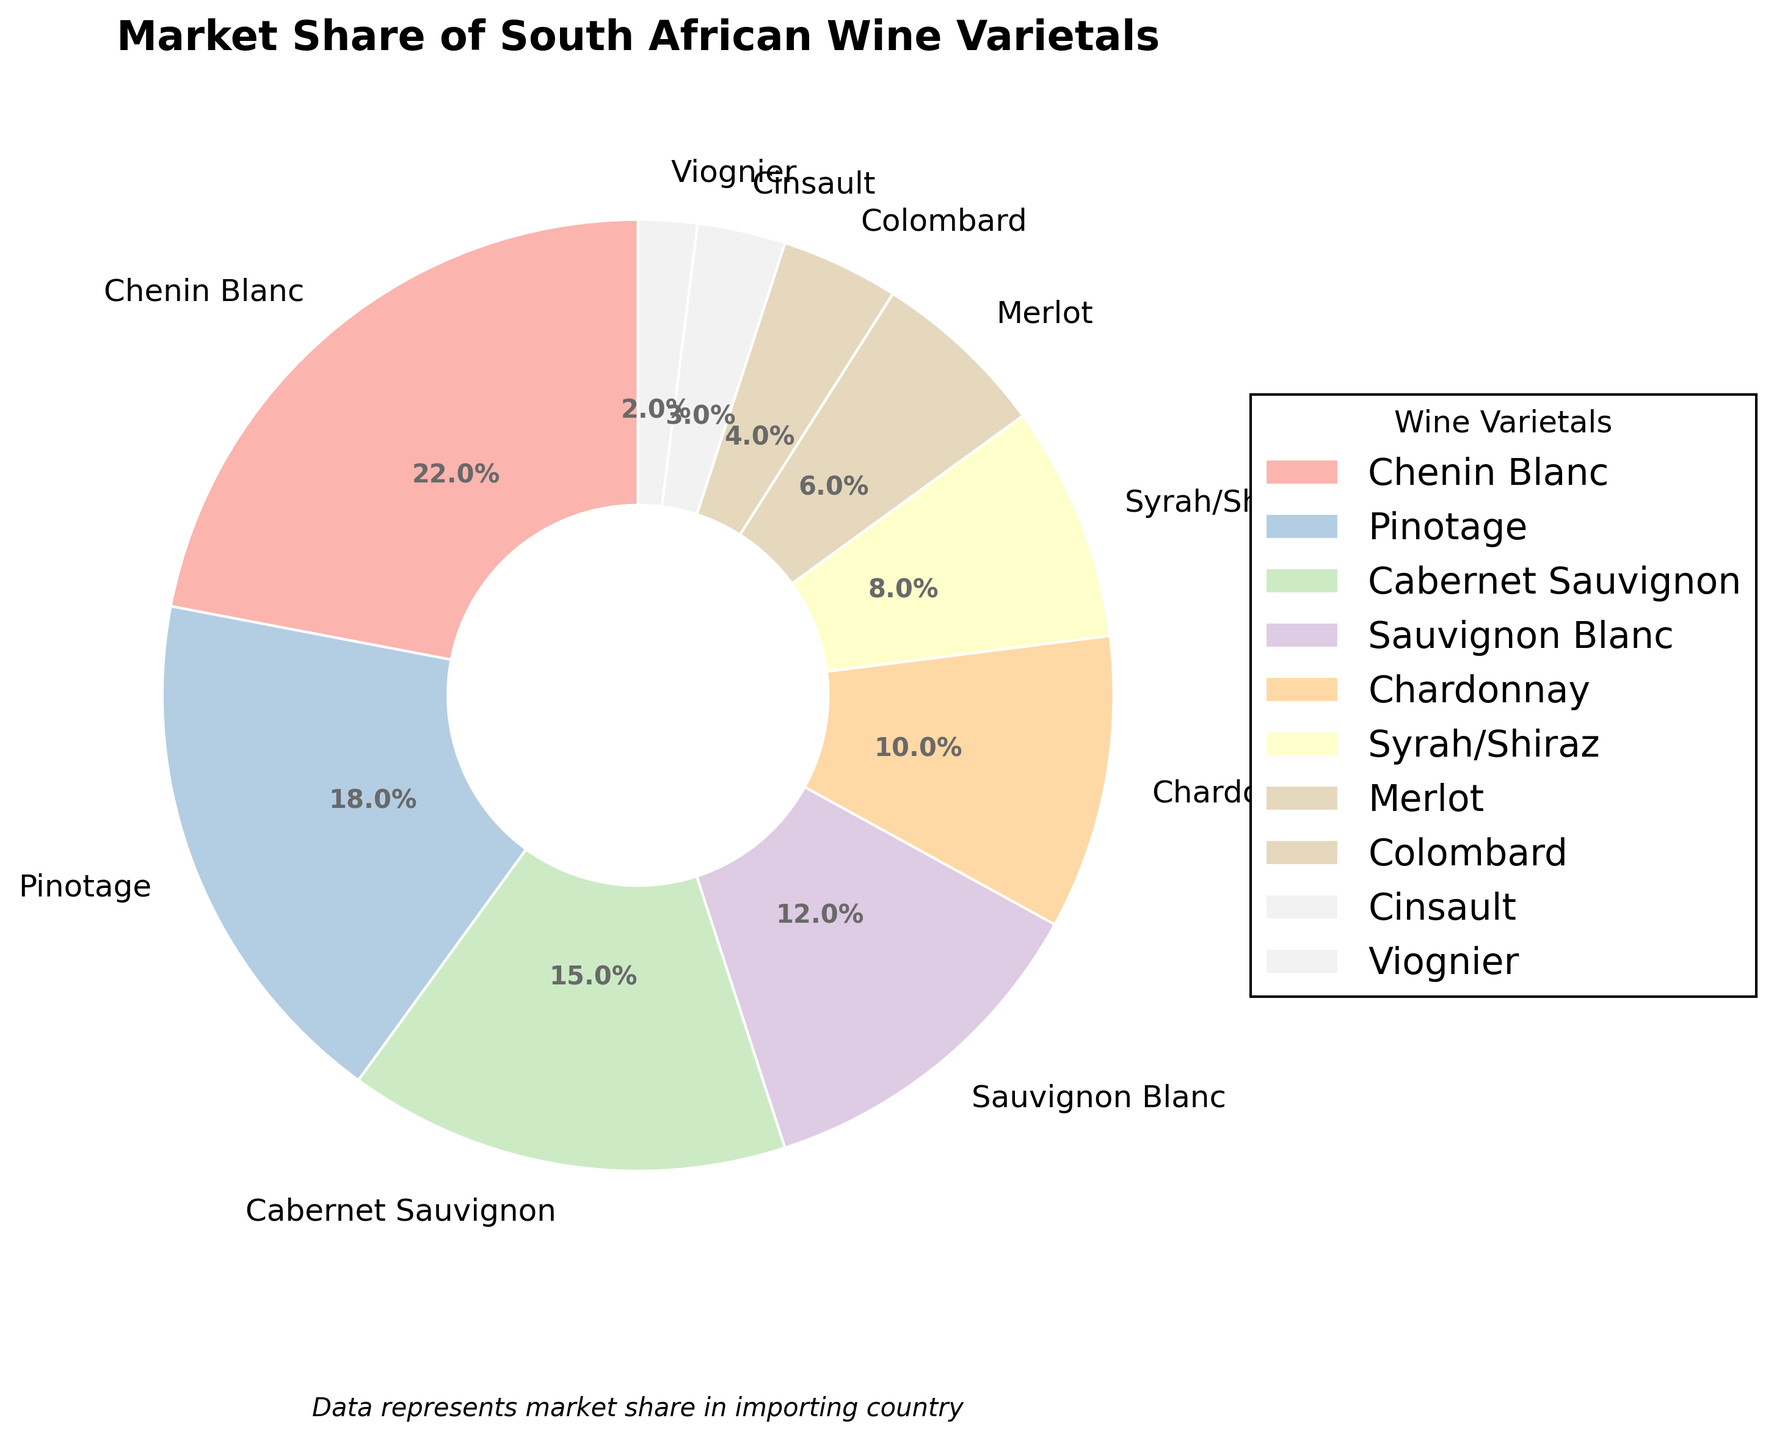Which varietal has the largest market share? By looking at the pie chart, the slice corresponding to Chenin Blanc is the largest one.
Answer: Chenin Blanc Which varietal has the smallest market share? By examining the pie chart, the smallest slice belongs to Viognier.
Answer: Viognier What is the total market share for Cabernet Sauvignon and Merlot? From the pie chart, Cabernet Sauvignon has a market share of 15% and Merlot has a market share of 6%. Adding these together, 15% + 6% = 21%.
Answer: 21% How does the market share of Pinotage compare to Chardonnay? The pie chart shows that Pinotage has a market share of 18%, which is larger than Chardonnay's 10%.
Answer: Pinotage has a larger market share than Chardonnay What two varietals have a combined market share equal to Chenin Blanc? Looking at the pie chart, Pinotage has 18% and Colombard has 4%. Adding these together, 18% + 4% = 22%, which matches Chenin Blanc’s market share.
Answer: Pinotage and Colombard What is the market share difference between Syrah/Shiraz and Sauvignon Blanc? The pie chart indicates Syrah/Shiraz has an 8% market share while Sauvignon Blanc has 12%. The difference is 12% - 8% = 4%.
Answer: 4% Which varietals have a market share of 10% or above? By examining the pie chart, Chenin Blanc, Pinotage, Cabernet Sauvignon, Sauvignon Blanc, and Chardonnay each have a market share of at least 10%.
Answer: Chenin Blanc, Pinotage, Cabernet Sauvignon, Sauvignon Blanc, Chardonnay How does the combined market share of Cinsault and Viognier compare to the combined share of Syrah/Shiraz and Merlot? Cinsault has 3% and Viognier 2%, adding to 5%. Syrah/Shiraz has 8% and Merlot 6%, adding to 14%. So, 14% is greater than 5%.
Answer: Syrah/Shiraz and Merlot have a larger combined market share Which varietal's market share is closest to the average market share of all varietals? To calculate the average, sum all market shares: 22 + 18 + 15 + 12 + 10 + 8 + 6 + 4 + 3 + 2 = 100%. The average share is 100% / 10 = 10%. Chardonnay has exactly a 10% market share, which matches the average.
Answer: Chardonnay 